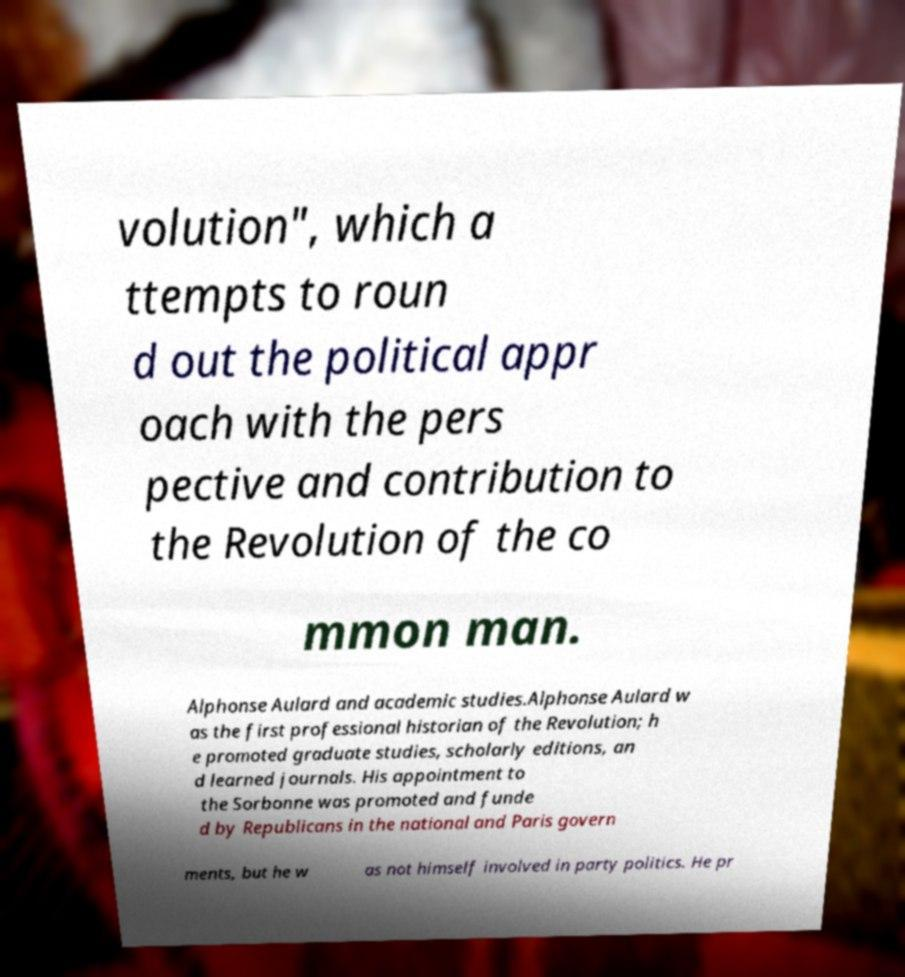Could you assist in decoding the text presented in this image and type it out clearly? volution", which a ttempts to roun d out the political appr oach with the pers pective and contribution to the Revolution of the co mmon man. Alphonse Aulard and academic studies.Alphonse Aulard w as the first professional historian of the Revolution; h e promoted graduate studies, scholarly editions, an d learned journals. His appointment to the Sorbonne was promoted and funde d by Republicans in the national and Paris govern ments, but he w as not himself involved in party politics. He pr 